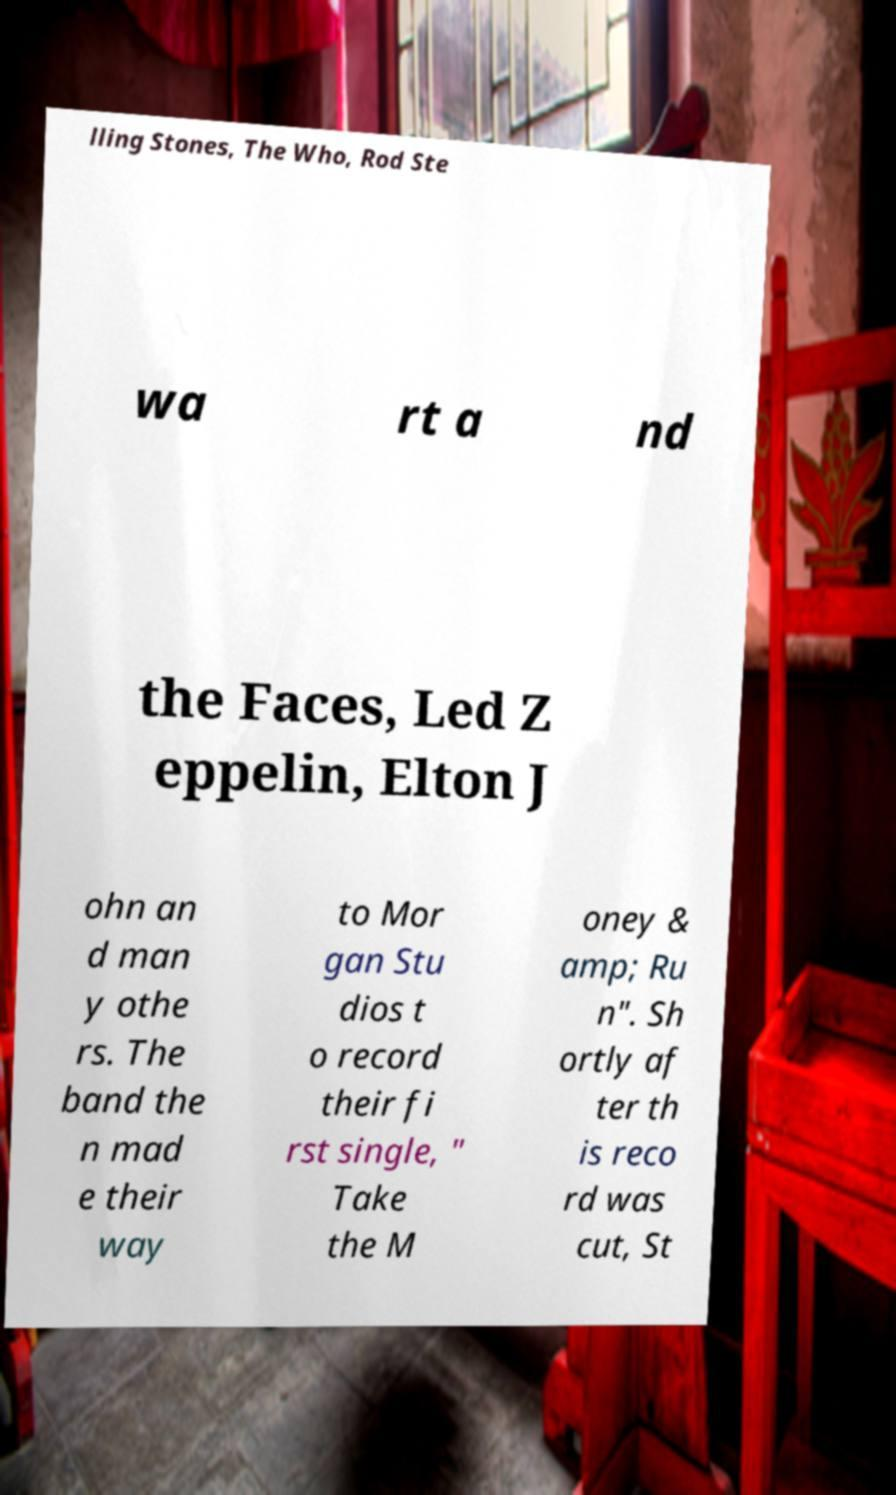What messages or text are displayed in this image? I need them in a readable, typed format. lling Stones, The Who, Rod Ste wa rt a nd the Faces, Led Z eppelin, Elton J ohn an d man y othe rs. The band the n mad e their way to Mor gan Stu dios t o record their fi rst single, " Take the M oney & amp; Ru n". Sh ortly af ter th is reco rd was cut, St 